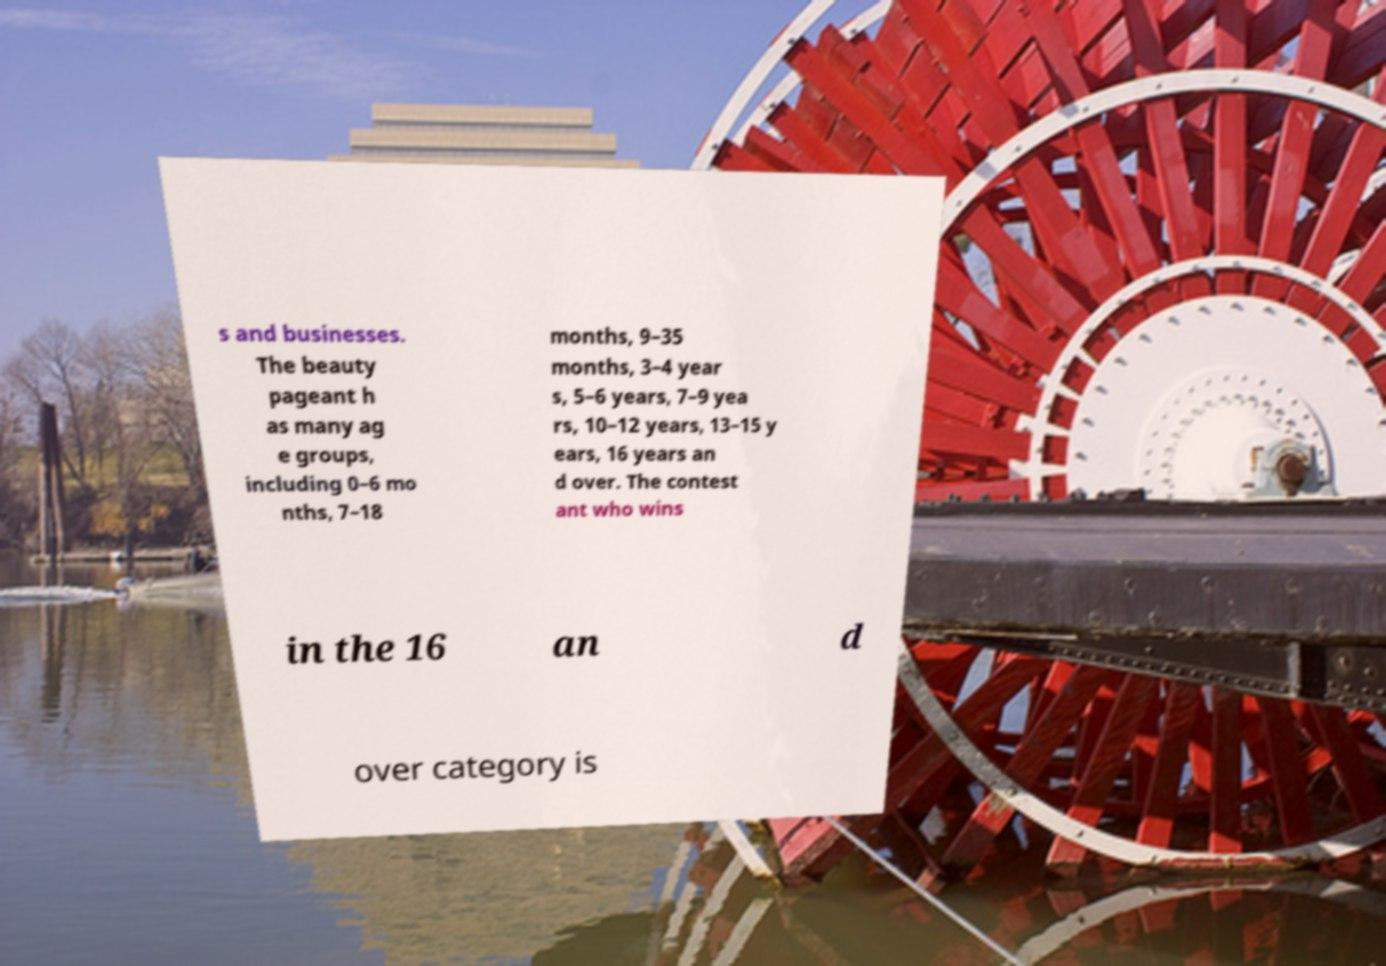Could you assist in decoding the text presented in this image and type it out clearly? s and businesses. The beauty pageant h as many ag e groups, including 0–6 mo nths, 7–18 months, 9–35 months, 3–4 year s, 5–6 years, 7–9 yea rs, 10–12 years, 13–15 y ears, 16 years an d over. The contest ant who wins in the 16 an d over category is 